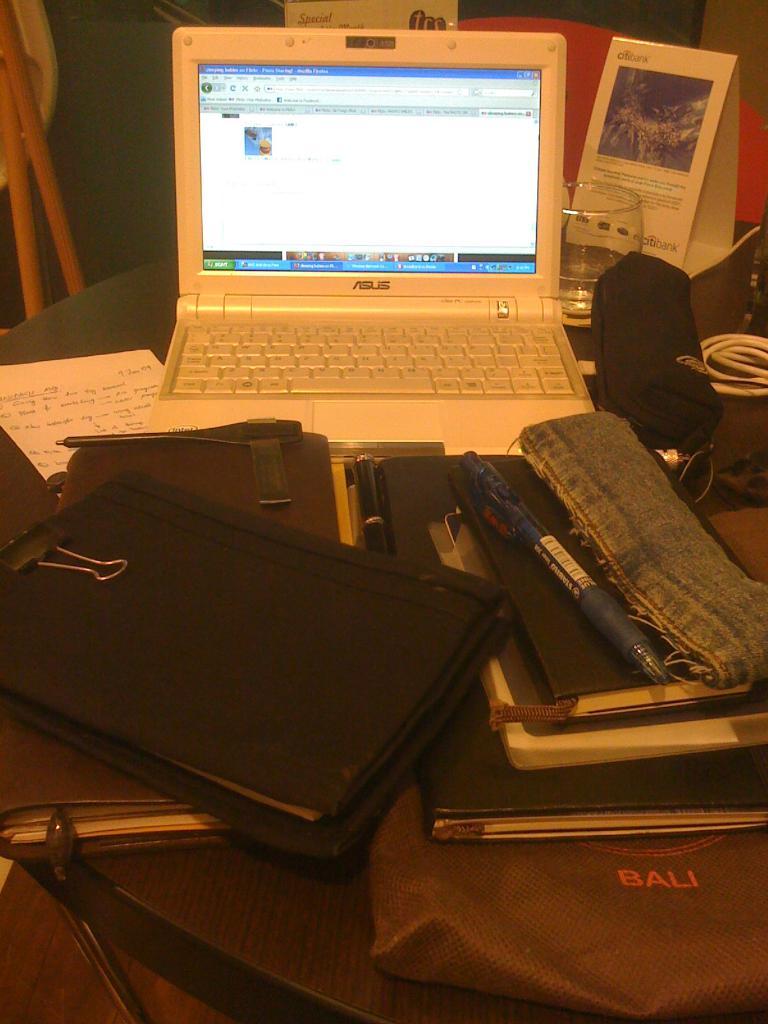What city is on the bag?
Your response must be concise. Bali. What brand is the laptop/?
Provide a short and direct response. Asus. 